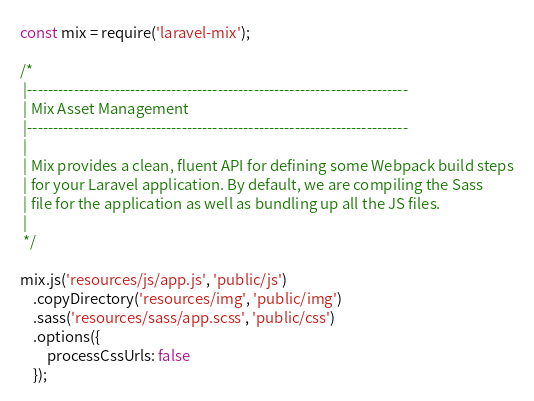Convert code to text. <code><loc_0><loc_0><loc_500><loc_500><_JavaScript_>const mix = require('laravel-mix');

/*
 |--------------------------------------------------------------------------
 | Mix Asset Management
 |--------------------------------------------------------------------------
 |
 | Mix provides a clean, fluent API for defining some Webpack build steps
 | for your Laravel application. By default, we are compiling the Sass
 | file for the application as well as bundling up all the JS files.
 |
 */

mix.js('resources/js/app.js', 'public/js')
    .copyDirectory('resources/img', 'public/img')
    .sass('resources/sass/app.scss', 'public/css')
    .options({
        processCssUrls: false
    });
</code> 